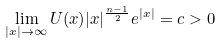<formula> <loc_0><loc_0><loc_500><loc_500>\lim _ { | x | \to \infty } U ( x ) | x | ^ { \frac { n - 1 } { 2 } } e ^ { | x | } = c > 0</formula> 